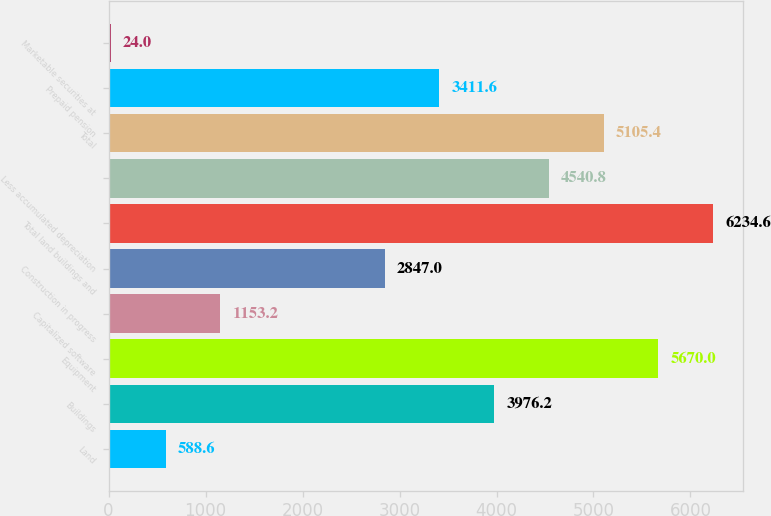Convert chart to OTSL. <chart><loc_0><loc_0><loc_500><loc_500><bar_chart><fcel>Land<fcel>Buildings<fcel>Equipment<fcel>Capitalized software<fcel>Construction in progress<fcel>Total land buildings and<fcel>Less accumulated depreciation<fcel>Total<fcel>Prepaid pension<fcel>Marketable securities at<nl><fcel>588.6<fcel>3976.2<fcel>5670<fcel>1153.2<fcel>2847<fcel>6234.6<fcel>4540.8<fcel>5105.4<fcel>3411.6<fcel>24<nl></chart> 